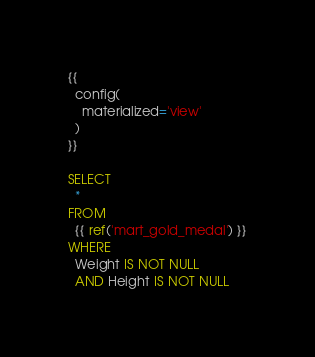Convert code to text. <code><loc_0><loc_0><loc_500><loc_500><_SQL_>{{
  config(
    materialized='view'
  )
}}

SELECT
  *
FROM
  {{ ref('mart_gold_medal') }}
WHERE
  Weight IS NOT NULL
  AND Height IS NOT NULL
</code> 